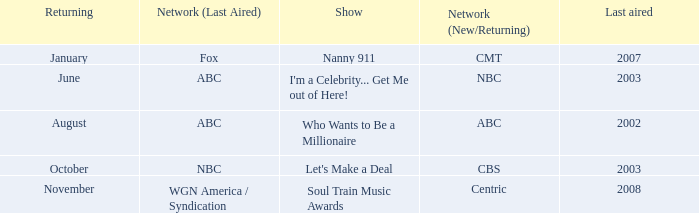When did soul train music awards return? November. 